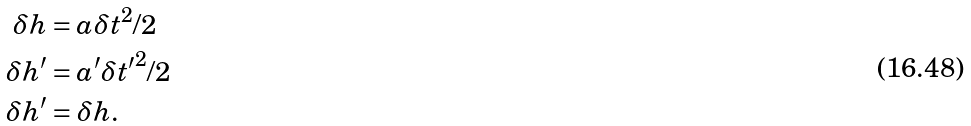Convert formula to latex. <formula><loc_0><loc_0><loc_500><loc_500>\delta h & = a \delta t ^ { 2 } / 2 \\ \delta h ^ { \prime } & = a ^ { \prime } \delta { t ^ { \prime } } ^ { 2 } / 2 \\ \delta h ^ { \prime } & = \delta h .</formula> 